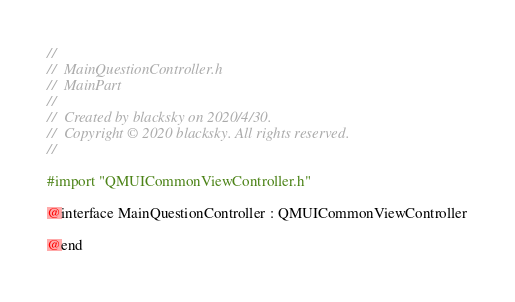Convert code to text. <code><loc_0><loc_0><loc_500><loc_500><_C_>//
//  MainQuestionController.h
//  MainPart
//
//  Created by blacksky on 2020/4/30.
//  Copyright © 2020 blacksky. All rights reserved.
//

#import "QMUICommonViewController.h"

@interface MainQuestionController : QMUICommonViewController

@end
</code> 